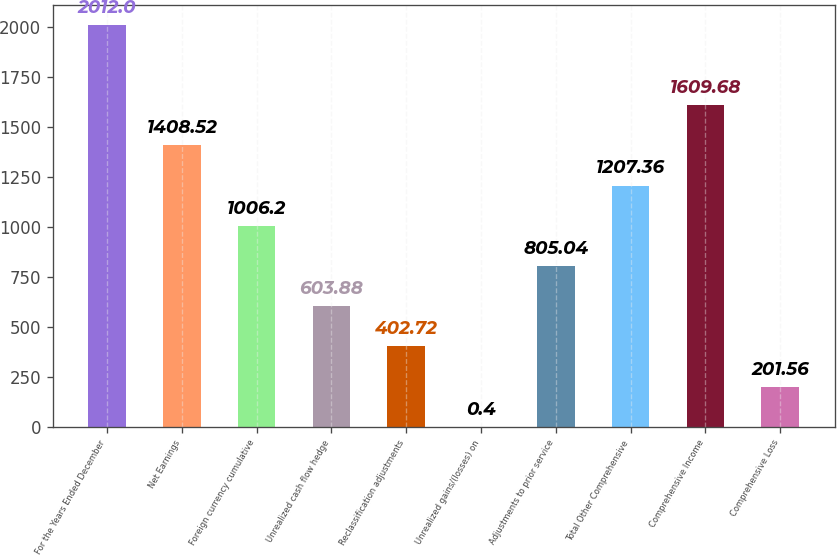Convert chart. <chart><loc_0><loc_0><loc_500><loc_500><bar_chart><fcel>For the Years Ended December<fcel>Net Earnings<fcel>Foreign currency cumulative<fcel>Unrealized cash flow hedge<fcel>Reclassification adjustments<fcel>Unrealized gains/(losses) on<fcel>Adjustments to prior service<fcel>Total Other Comprehensive<fcel>Comprehensive Income<fcel>Comprehensive Loss<nl><fcel>2012<fcel>1408.52<fcel>1006.2<fcel>603.88<fcel>402.72<fcel>0.4<fcel>805.04<fcel>1207.36<fcel>1609.68<fcel>201.56<nl></chart> 